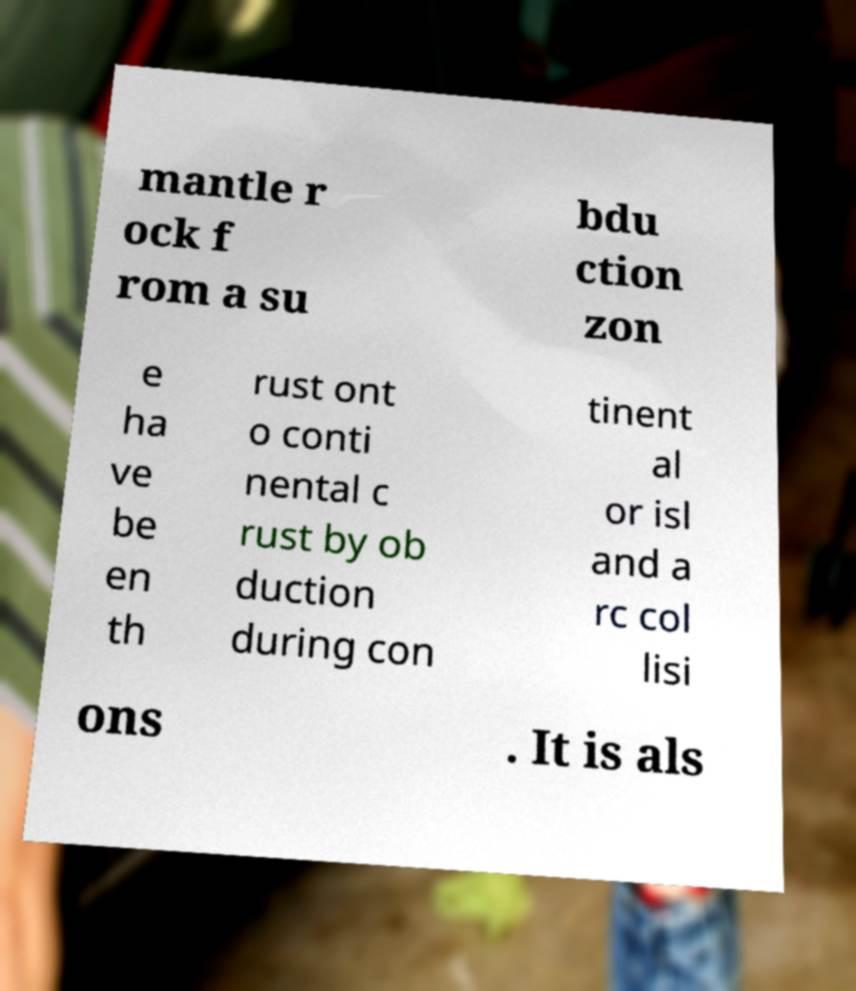I need the written content from this picture converted into text. Can you do that? mantle r ock f rom a su bdu ction zon e ha ve be en th rust ont o conti nental c rust by ob duction during con tinent al or isl and a rc col lisi ons . It is als 